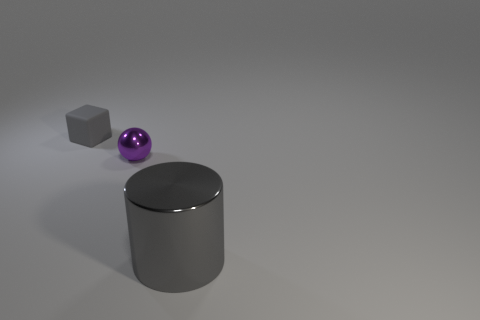What is the color of the thing that is in front of the small gray object and on the left side of the large cylinder?
Make the answer very short. Purple. What is the size of the rubber thing that is the same color as the big metallic cylinder?
Your answer should be very brief. Small. How many large things are either purple objects or gray objects?
Provide a short and direct response. 1. Are there any other things that have the same color as the shiny sphere?
Ensure brevity in your answer.  No. The gray thing to the left of the metal thing that is right of the metal thing on the left side of the large metallic object is made of what material?
Give a very brief answer. Rubber. What number of shiny objects are big cylinders or small gray objects?
Your answer should be very brief. 1. What number of gray things are small shiny balls or large metallic things?
Offer a very short reply. 1. Is the color of the metallic object on the right side of the purple shiny object the same as the shiny ball?
Offer a very short reply. No. Is the material of the big object the same as the small gray object?
Your response must be concise. No. Is the number of matte blocks that are on the right side of the purple metal thing the same as the number of small gray matte things behind the cube?
Keep it short and to the point. Yes. 